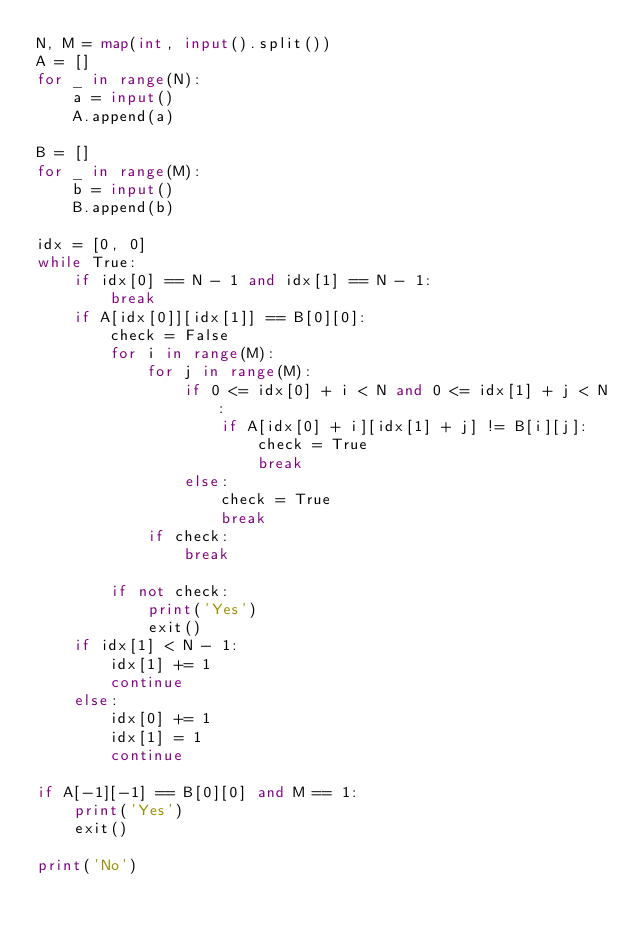Convert code to text. <code><loc_0><loc_0><loc_500><loc_500><_Python_>N, M = map(int, input().split())
A = []
for _ in range(N):
    a = input()
    A.append(a)

B = []
for _ in range(M):
    b = input()
    B.append(b)

idx = [0, 0]
while True:
    if idx[0] == N - 1 and idx[1] == N - 1:
        break
    if A[idx[0]][idx[1]] == B[0][0]:
        check = False
        for i in range(M):
            for j in range(M):
                if 0 <= idx[0] + i < N and 0 <= idx[1] + j < N:
                    if A[idx[0] + i][idx[1] + j] != B[i][j]:
                        check = True
                        break
                else:
                    check = True
                    break
            if check:
                break

        if not check:
            print('Yes')
            exit()
    if idx[1] < N - 1:
        idx[1] += 1
        continue
    else:
        idx[0] += 1
        idx[1] = 1
        continue

if A[-1][-1] == B[0][0] and M == 1:
    print('Yes')
    exit()

print('No')
</code> 